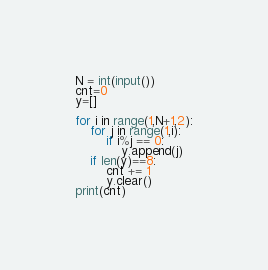<code> <loc_0><loc_0><loc_500><loc_500><_Python_>N = int(input())
cnt=0
y=[]

for i in range(1,N+1,2):
    for j in range(1,i):
        if i%j == 0:
            y.append(j)
    if len(y)==8:
        cnt += 1
        y.clear()
print(cnt)</code> 